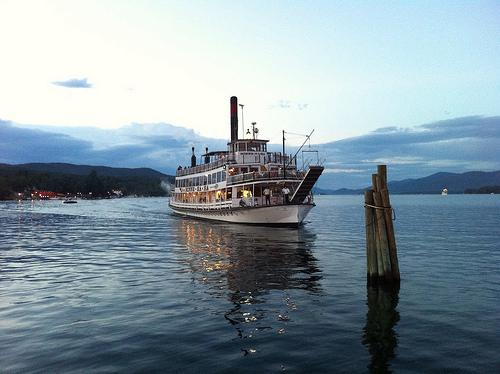Provide a short caption to summarize the scene in the image. A large boat cruising on calm water surrounded by wooden posts, with people working on board and scenic landscape in the background. Identify the type of boat in the image and describe one unique feature about it. It is a white triple-decker boat with a tall smokestack. Describe the weather and the sky in the image. The sky is partly cloudy with some white and black clouds, giving a sense of the sun setting over calm waters. Point out a notable interaction between two objects in the image. The lights on the boat hint at its interior activity, reflecting off the calm water and illuminating the otherwise serene scene. Explain the state of the water and the effect it has on its surroundings. The water is calm and reflective, creating a peaceful atmosphere and emphasizing the boat's reflection. What type of landscape can be seen in the background of the image? A shoreline with houses and buildings, tall mountains in the distance, and dark clouds in a partly cloudy sky. What is going on at the shore in the background of the image? There are houses and buildings dotted along the shoreline, with a few boats moored nearby, and a docking station on the land. Count the number of people visible on the boat and describe their attire. There are 3 men on the boat, all wearing white shirts. How can the potential mood or sentiment of this image be described? The image evokes tranquility and serenity, with a sense of peaceful adventure. What is the primary mode of transportation depicted in the image? The primary mode of transportation is boats. Are the lights on the exterior of the ship turned on? Yes, the lights on the exterior of the ship are turned on. Locate the purple elephant with a party hat near the shoreline. This instruction is misleading as it mentions an object (purple elephant with a party hat) that is highly unlikely to exist in the given scene. The scene describes a calm water setting with boats and natural elements, which does not fit the context of an elephant with a party hat. What kind of uniform is the man wearing in the image? The man is wearing a white shirt as part of a uniform. Identify the key elements in the sky of the image. The sky has fluffy white clouds and some dark clouds. Can you spot any text in the image to identify for OCR task? No visible text is present in the image. A family of ducks swims near the wooden posts in the water. How many ducklings are there? No, it's not mentioned in the image. Detect any unusual objects or occurrences in the image. No unusual objects or occurrences are detected in the image. List the objects and their respective attributes found in the image. Calm blue waters, white boats, people in white shirts, wooden posts, houses on the shoreline, and a tall mountain range. Which of the following options correctly identifies the state of the water in the image: a) turbulent water, b) calm water, c) clear water? b) calm water Which object is being described as "wooden marker jutting out of water"? The wooden posts sticking out of the water. Find and describe the state of the clouds in the sky. There are dark clouds in a partly cloudy sky. What is the main color of the boat in the image? The main color of the boat is white. Describe the overall sentiment of the image. The image has a calm and peaceful sentiment. Identify the main elements and structures found in the image. Calm blue waters, boats, people, wooden posts, shoreline, houses, and mountain range. Identify the interaction between the men and the boat in the image. The men are working on the boat, standing on the deck. Evaluate the quality of the image. The image quality is clear with a good amount of detail. Is there any indication of motion in the image relating to the movement of the boats? No, there is no apparent motion of the boats in the image. Determine the attributes of the boat, like color and structure. The boat is white, large, and has a tall stack. Describe the background elements behind the boats in the image. There is a shoreline with houses and a tall mountain range in the background. What is the color of the water in the image? The water in the image is calm blue. 